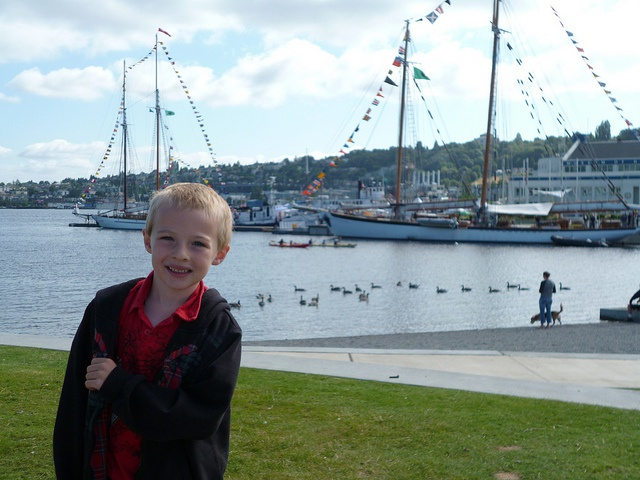Describe the objects in this image and their specific colors. I can see people in lightblue, black, gray, maroon, and darkgray tones, boat in lightblue, gray, blue, black, and navy tones, bird in lightblue, darkgray, and gray tones, boat in lightblue, blue, gray, and navy tones, and boat in lightblue, gray, blue, and black tones in this image. 